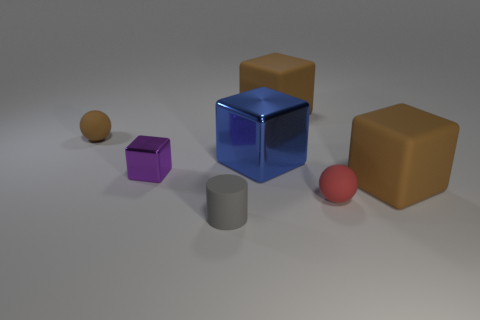Subtract all small purple metallic blocks. How many blocks are left? 3 Subtract all yellow cylinders. How many brown blocks are left? 2 Add 1 blue metallic objects. How many objects exist? 8 Subtract 1 blocks. How many blocks are left? 3 Subtract all purple blocks. How many blocks are left? 3 Subtract all cubes. How many objects are left? 3 Add 7 small rubber objects. How many small rubber objects are left? 10 Add 5 blue metallic things. How many blue metallic things exist? 6 Subtract 0 cyan spheres. How many objects are left? 7 Subtract all red cylinders. Subtract all blue cubes. How many cylinders are left? 1 